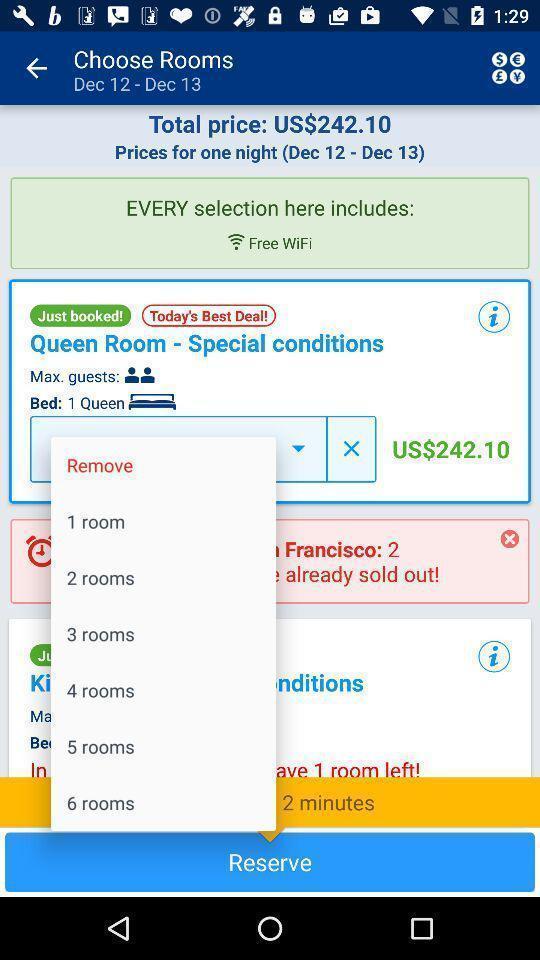Give me a narrative description of this picture. Screen shows to choose rooms. 